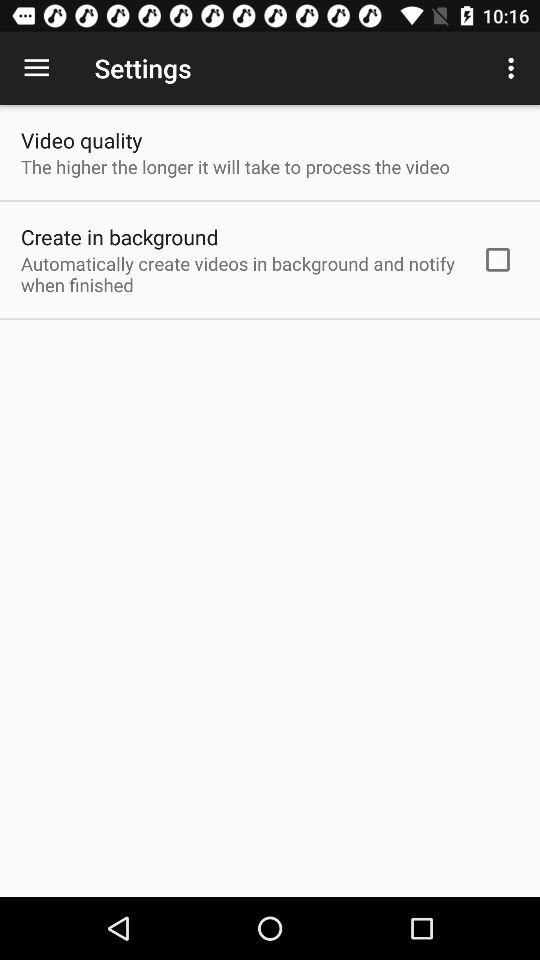How high is the video quality?
When the provided information is insufficient, respond with <no answer>. <no answer> 